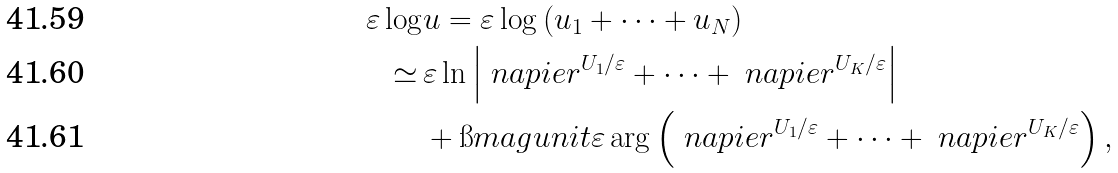<formula> <loc_0><loc_0><loc_500><loc_500>\varepsilon \log & u = \varepsilon \log \left ( u _ { 1 } + \cdots + u _ { N } \right ) \\ \simeq \, & \varepsilon \ln \left | \ n a p i e r ^ { U _ { 1 } / \varepsilon } + \cdots + \ n a p i e r ^ { U _ { K } / \varepsilon } \right | \\ & + \i m a g u n i t \varepsilon \arg \left ( \ n a p i e r ^ { U _ { 1 } / \varepsilon } + \cdots + \ n a p i e r ^ { U _ { K } / \varepsilon } \right ) ,</formula> 